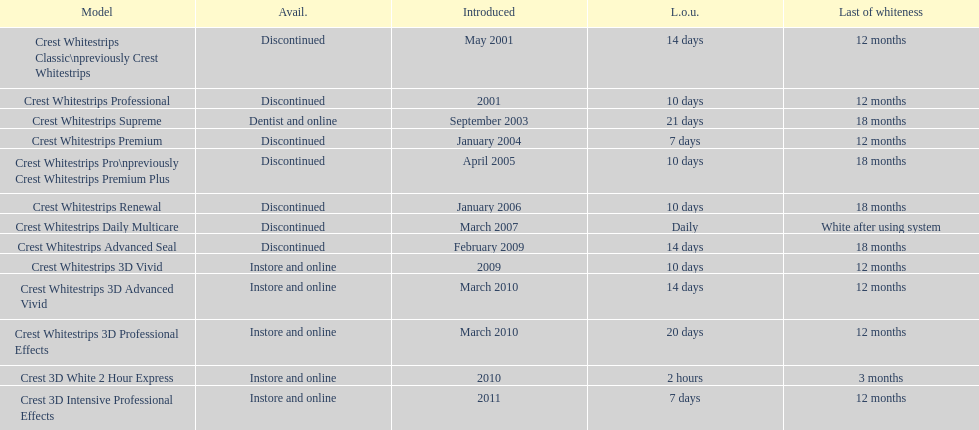Would you be able to parse every entry in this table? {'header': ['Model', 'Avail.', 'Introduced', 'L.o.u.', 'Last of whiteness'], 'rows': [['Crest Whitestrips Classic\\npreviously Crest Whitestrips', 'Discontinued', 'May 2001', '14 days', '12 months'], ['Crest Whitestrips Professional', 'Discontinued', '2001', '10 days', '12 months'], ['Crest Whitestrips Supreme', 'Dentist and online', 'September 2003', '21 days', '18 months'], ['Crest Whitestrips Premium', 'Discontinued', 'January 2004', '7 days', '12 months'], ['Crest Whitestrips Pro\\npreviously Crest Whitestrips Premium Plus', 'Discontinued', 'April 2005', '10 days', '18 months'], ['Crest Whitestrips Renewal', 'Discontinued', 'January 2006', '10 days', '18 months'], ['Crest Whitestrips Daily Multicare', 'Discontinued', 'March 2007', 'Daily', 'White after using system'], ['Crest Whitestrips Advanced Seal', 'Discontinued', 'February 2009', '14 days', '18 months'], ['Crest Whitestrips 3D Vivid', 'Instore and online', '2009', '10 days', '12 months'], ['Crest Whitestrips 3D Advanced Vivid', 'Instore and online', 'March 2010', '14 days', '12 months'], ['Crest Whitestrips 3D Professional Effects', 'Instore and online', 'March 2010', '20 days', '12 months'], ['Crest 3D White 2 Hour Express', 'Instore and online', '2010', '2 hours', '3 months'], ['Crest 3D Intensive Professional Effects', 'Instore and online', '2011', '7 days', '12 months']]} Which terminated product made its debut alongside crest whitestrips 3d vivid? Crest Whitestrips Advanced Seal. 